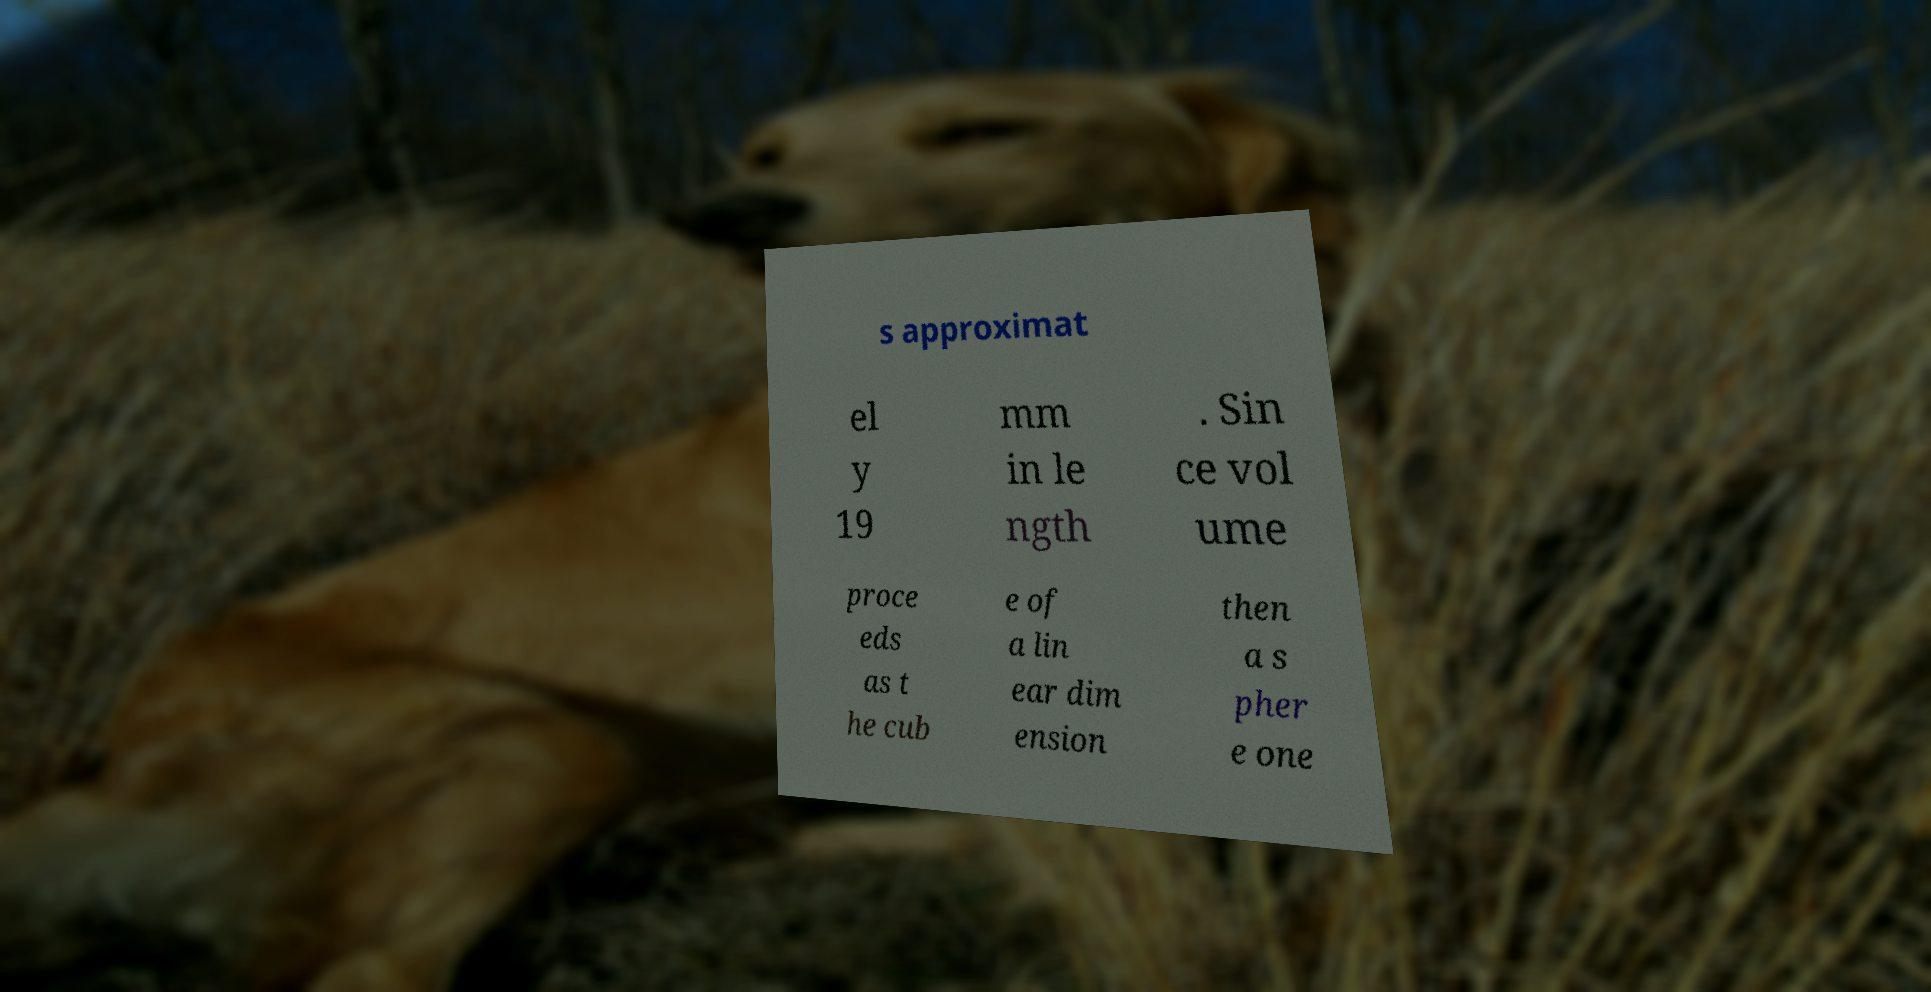Please read and relay the text visible in this image. What does it say? s approximat el y 19 mm in le ngth . Sin ce vol ume proce eds as t he cub e of a lin ear dim ension then a s pher e one 